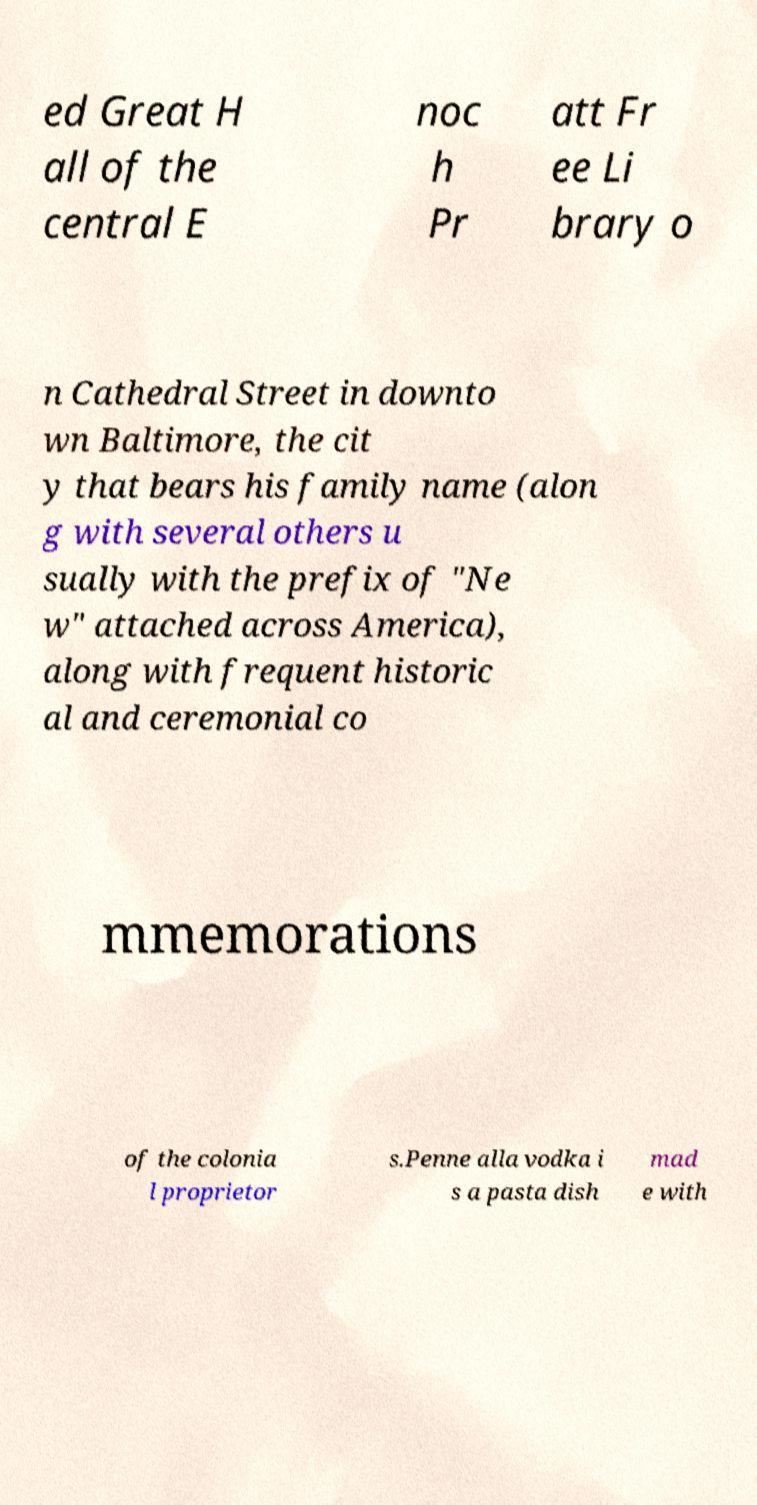I need the written content from this picture converted into text. Can you do that? ed Great H all of the central E noc h Pr att Fr ee Li brary o n Cathedral Street in downto wn Baltimore, the cit y that bears his family name (alon g with several others u sually with the prefix of "Ne w" attached across America), along with frequent historic al and ceremonial co mmemorations of the colonia l proprietor s.Penne alla vodka i s a pasta dish mad e with 